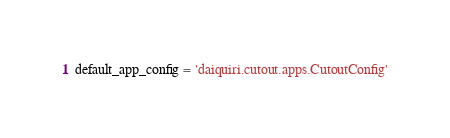<code> <loc_0><loc_0><loc_500><loc_500><_Python_>default_app_config = 'daiquiri.cutout.apps.CutoutConfig'
</code> 